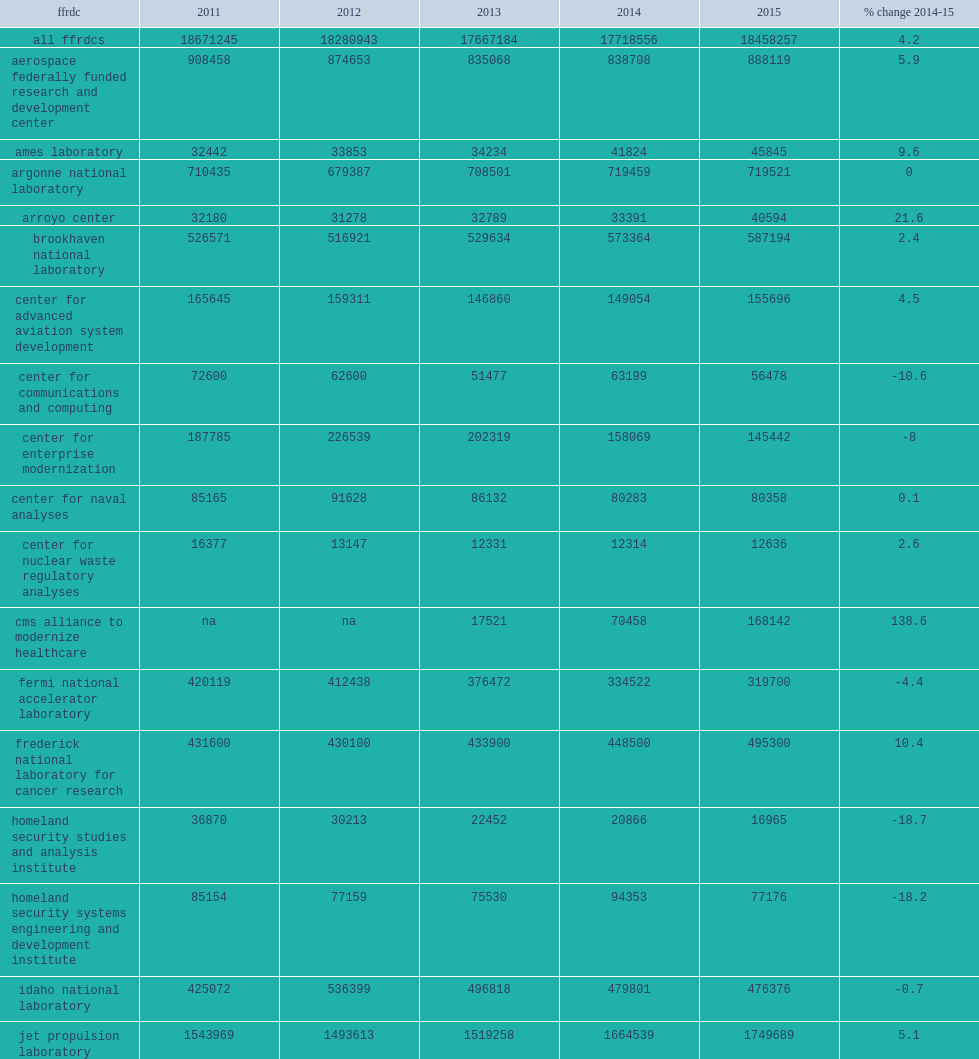Lawrence livermore national laboratory showed the most growth of these six, how many percent of increasing in current dollars between 2014 and 2015 following a decline reported in fy 2014? 8.8. How many percent did pacific northwest national laboratory report a spending decline in fy 2015? 6.9. 